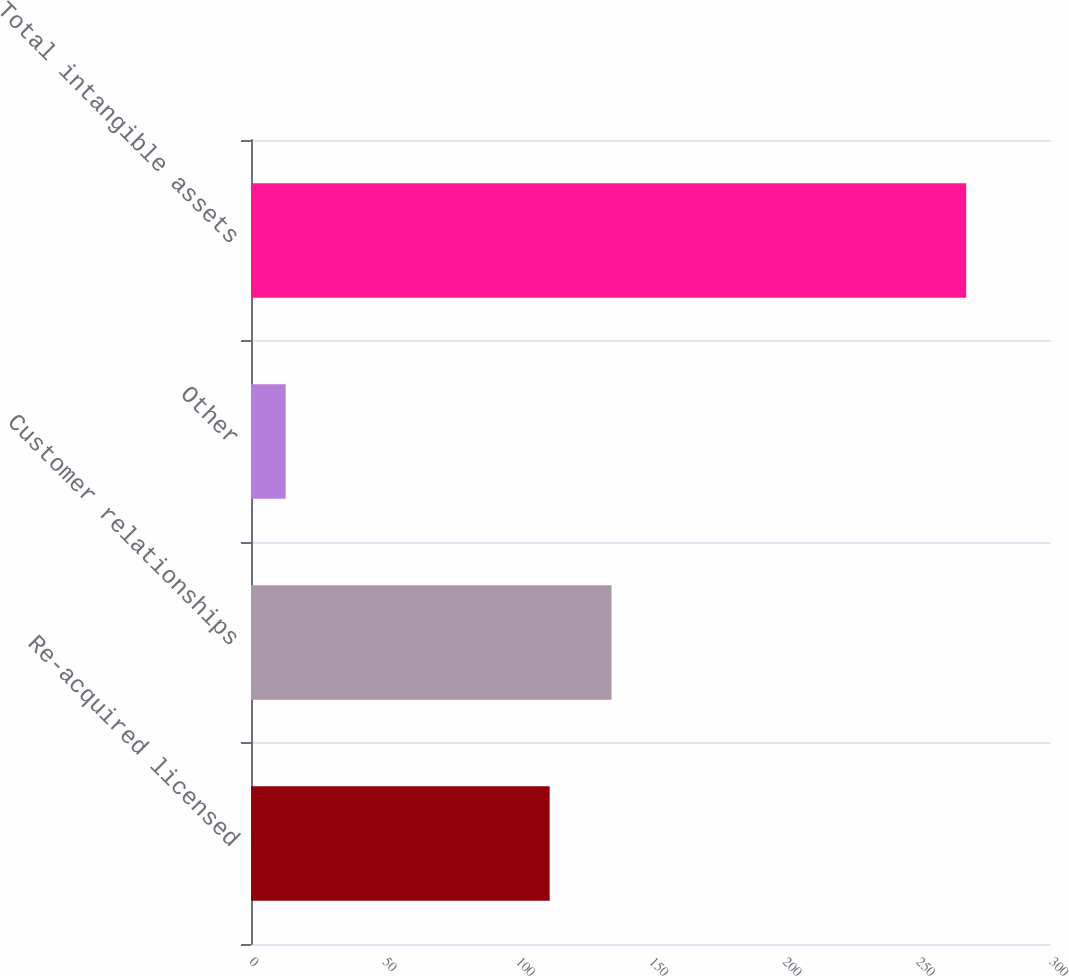Convert chart. <chart><loc_0><loc_0><loc_500><loc_500><bar_chart><fcel>Re-acquired licensed<fcel>Customer relationships<fcel>Other<fcel>Total intangible assets<nl><fcel>112<fcel>135.2<fcel>13<fcel>268.2<nl></chart> 